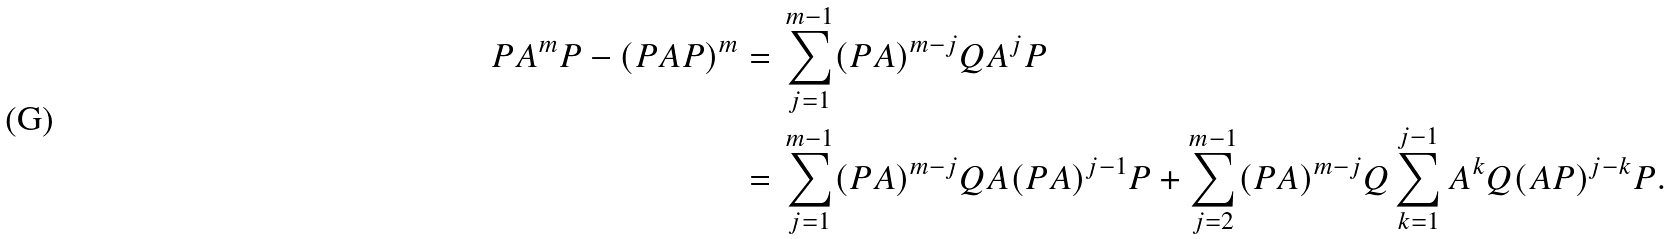<formula> <loc_0><loc_0><loc_500><loc_500>P A ^ { m } P - ( P A P ) ^ { m } = & \ \sum _ { j = 1 } ^ { m - 1 } ( P A ) ^ { m - j } Q A ^ { j } P \\ = & \ \sum _ { j = 1 } ^ { m - 1 } ( P A ) ^ { m - j } Q A ( P A ) ^ { j - 1 } P + \sum _ { j = 2 } ^ { m - 1 } ( P A ) ^ { m - j } Q \sum _ { k = 1 } ^ { j - 1 } A ^ { k } Q ( A P ) ^ { j - k } P .</formula> 